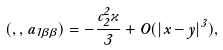Convert formula to latex. <formula><loc_0><loc_0><loc_500><loc_500>( \Phi , \Phi , a _ { 1 \beta \beta } ) = - \frac { c _ { 2 } ^ { 2 } \varkappa } { 3 } + O ( | x - y | ^ { 3 } ) ,</formula> 